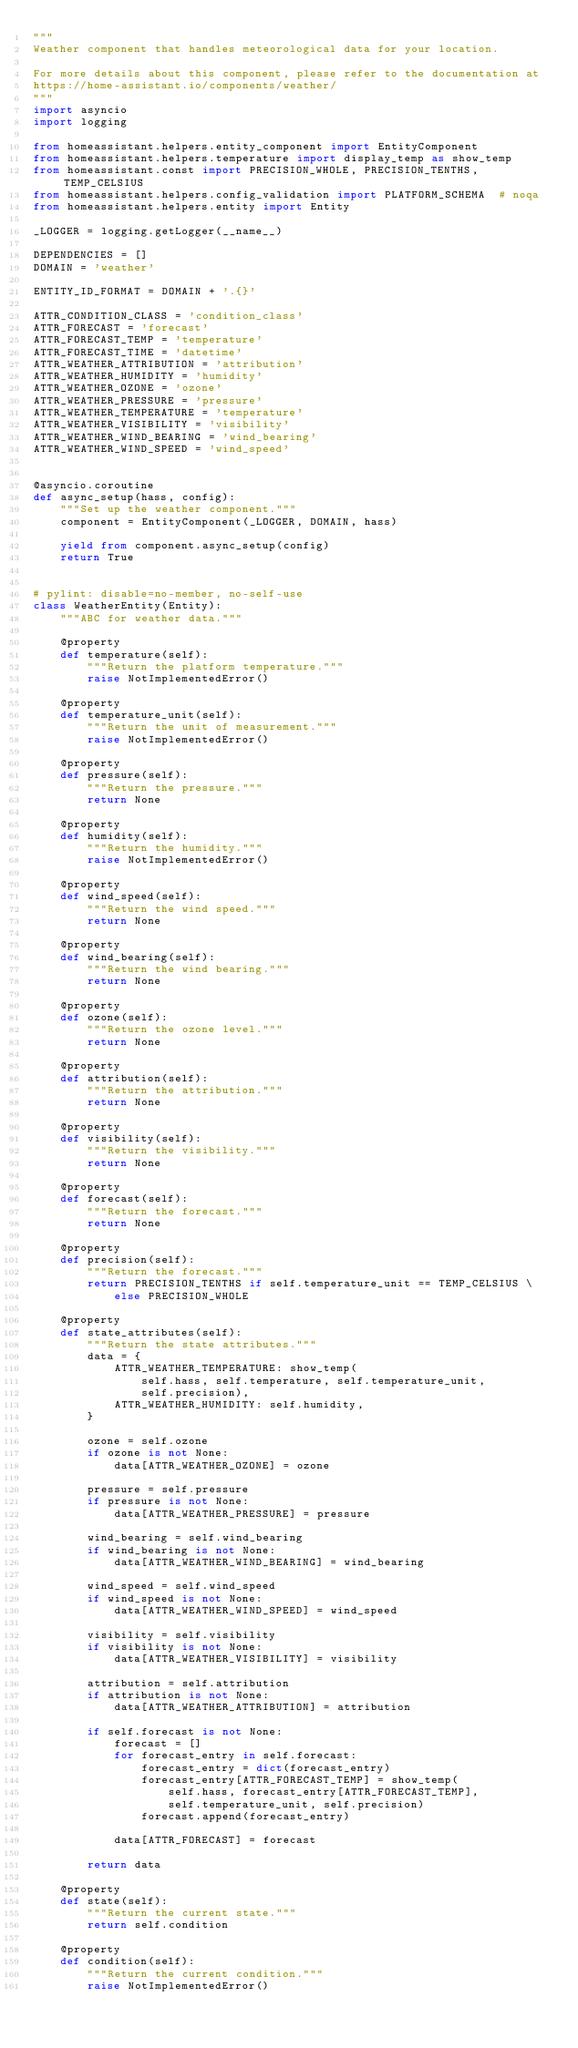Convert code to text. <code><loc_0><loc_0><loc_500><loc_500><_Python_>"""
Weather component that handles meteorological data for your location.

For more details about this component, please refer to the documentation at
https://home-assistant.io/components/weather/
"""
import asyncio
import logging

from homeassistant.helpers.entity_component import EntityComponent
from homeassistant.helpers.temperature import display_temp as show_temp
from homeassistant.const import PRECISION_WHOLE, PRECISION_TENTHS, TEMP_CELSIUS
from homeassistant.helpers.config_validation import PLATFORM_SCHEMA  # noqa
from homeassistant.helpers.entity import Entity

_LOGGER = logging.getLogger(__name__)

DEPENDENCIES = []
DOMAIN = 'weather'

ENTITY_ID_FORMAT = DOMAIN + '.{}'

ATTR_CONDITION_CLASS = 'condition_class'
ATTR_FORECAST = 'forecast'
ATTR_FORECAST_TEMP = 'temperature'
ATTR_FORECAST_TIME = 'datetime'
ATTR_WEATHER_ATTRIBUTION = 'attribution'
ATTR_WEATHER_HUMIDITY = 'humidity'
ATTR_WEATHER_OZONE = 'ozone'
ATTR_WEATHER_PRESSURE = 'pressure'
ATTR_WEATHER_TEMPERATURE = 'temperature'
ATTR_WEATHER_VISIBILITY = 'visibility'
ATTR_WEATHER_WIND_BEARING = 'wind_bearing'
ATTR_WEATHER_WIND_SPEED = 'wind_speed'


@asyncio.coroutine
def async_setup(hass, config):
    """Set up the weather component."""
    component = EntityComponent(_LOGGER, DOMAIN, hass)

    yield from component.async_setup(config)
    return True


# pylint: disable=no-member, no-self-use
class WeatherEntity(Entity):
    """ABC for weather data."""

    @property
    def temperature(self):
        """Return the platform temperature."""
        raise NotImplementedError()

    @property
    def temperature_unit(self):
        """Return the unit of measurement."""
        raise NotImplementedError()

    @property
    def pressure(self):
        """Return the pressure."""
        return None

    @property
    def humidity(self):
        """Return the humidity."""
        raise NotImplementedError()

    @property
    def wind_speed(self):
        """Return the wind speed."""
        return None

    @property
    def wind_bearing(self):
        """Return the wind bearing."""
        return None

    @property
    def ozone(self):
        """Return the ozone level."""
        return None

    @property
    def attribution(self):
        """Return the attribution."""
        return None

    @property
    def visibility(self):
        """Return the visibility."""
        return None

    @property
    def forecast(self):
        """Return the forecast."""
        return None

    @property
    def precision(self):
        """Return the forecast."""
        return PRECISION_TENTHS if self.temperature_unit == TEMP_CELSIUS \
            else PRECISION_WHOLE

    @property
    def state_attributes(self):
        """Return the state attributes."""
        data = {
            ATTR_WEATHER_TEMPERATURE: show_temp(
                self.hass, self.temperature, self.temperature_unit,
                self.precision),
            ATTR_WEATHER_HUMIDITY: self.humidity,
        }

        ozone = self.ozone
        if ozone is not None:
            data[ATTR_WEATHER_OZONE] = ozone

        pressure = self.pressure
        if pressure is not None:
            data[ATTR_WEATHER_PRESSURE] = pressure

        wind_bearing = self.wind_bearing
        if wind_bearing is not None:
            data[ATTR_WEATHER_WIND_BEARING] = wind_bearing

        wind_speed = self.wind_speed
        if wind_speed is not None:
            data[ATTR_WEATHER_WIND_SPEED] = wind_speed

        visibility = self.visibility
        if visibility is not None:
            data[ATTR_WEATHER_VISIBILITY] = visibility

        attribution = self.attribution
        if attribution is not None:
            data[ATTR_WEATHER_ATTRIBUTION] = attribution

        if self.forecast is not None:
            forecast = []
            for forecast_entry in self.forecast:
                forecast_entry = dict(forecast_entry)
                forecast_entry[ATTR_FORECAST_TEMP] = show_temp(
                    self.hass, forecast_entry[ATTR_FORECAST_TEMP],
                    self.temperature_unit, self.precision)
                forecast.append(forecast_entry)

            data[ATTR_FORECAST] = forecast

        return data

    @property
    def state(self):
        """Return the current state."""
        return self.condition

    @property
    def condition(self):
        """Return the current condition."""
        raise NotImplementedError()
</code> 